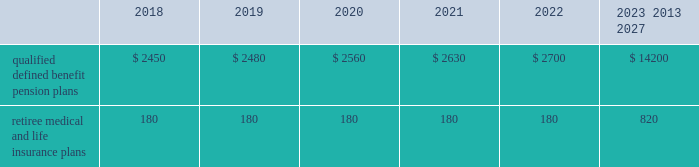U.s .
Equity securities and international equity securities categorized as level 1 are traded on active national and international exchanges and are valued at their closing prices on the last trading day of the year .
For u.s .
Equity securities and international equity securities not traded on an active exchange , or if the closing price is not available , the trustee obtains indicative quotes from a pricing vendor , broker or investment manager .
These securities are categorized as level 2 if the custodian obtains corroborated quotes from a pricing vendor or categorized as level 3 if the custodian obtains uncorroborated quotes from a broker or investment manager .
Commingled equity funds categorized as level 1 are traded on active national and international exchanges and are valued at their closing prices on the last trading day of the year .
For commingled equity funds not traded on an active exchange , or if the closing price is not available , the trustee obtains indicative quotes from a pricing vendor , broker or investment manager .
These securities are categorized as level 2 if the custodian obtains corroborated quotes from a pricing vendor .
Fixed income investments categorized as level 2 are valued by the trustee using pricing models that use verifiable observable market data ( e.g. , interest rates and yield curves observable at commonly quoted intervals and credit spreads ) , bids provided by brokers or dealers or quoted prices of securities with similar characteristics .
Fixed income investments are categorized at level 3 when valuations using observable inputs are unavailable .
The trustee obtains pricing based on indicative quotes or bid evaluations from vendors , brokers or the investment manager .
Commodities are traded on an active commodity exchange and are valued at their closing prices on the last trading day of the certain commingled equity funds , consisting of equity mutual funds , are valued using the nav.aa thenavaa valuations are based on the underlying investments and typically redeemable within 90 days .
Private equity funds consist of partnership and co-investment funds .
The navaa is based on valuation models of the underlying securities , which includes unobservable inputs that cannot be corroborated using verifiable observable market data .
These funds typically have redemption periods between eight and 12 years .
Real estate funds consist of partnerships , most of which are closed-end funds , for which the navaa is based on valuationmodels and periodic appraisals .
These funds typically have redemption periods between eight and 10 years .
Hedge funds consist of direct hedge funds forwhich thenavaa is generally based on the valuation of the underlying investments .
Redemptions in hedge funds are based on the specific terms of each fund , and generally range from a minimum of one month to several months .
Contributions and expected benefit payments the funding of our qualified defined benefit pension plans is determined in accordance with erisa , as amended by the ppa , and in a manner consistent with cas and internal revenue code rules .
There were no material contributions to our qualified defined benefit pension plans during 2017 .
We will make contributions of $ 5.0 billion to our qualified defined benefit pension plans in 2018 , including required and discretionary contributions.as a result of these contributions , we do not expect any material qualified defined benefit cash funding will be required until 2021.we plan to fund these contributions using a mix of cash on hand and commercial paper .
While we do not anticipate a need to do so , our capital structure and resources would allow us to issue new debt if circumstances change .
The table presents estimated future benefit payments , which reflect expected future employee service , as of december 31 , 2017 ( in millions ) : .
Defined contribution plans wemaintain a number of defined contribution plans , most with 401 ( k ) features , that cover substantially all of our employees .
Under the provisions of our 401 ( k ) plans , wematchmost employees 2019 eligible contributions at rates specified in the plan documents .
Our contributions were $ 613 million in 2017 , $ 617 million in 2016 and $ 393 million in 2015 , the majority of which were funded using our common stock .
Our defined contribution plans held approximately 35.5 million and 36.9 million shares of our common stock as of december 31 , 2017 and 2016. .
What was the percentage change in the employee total matching contributions from 2015 to 2016? 
Computations: ((617 - 393) / 393)
Answer: 0.56997. 